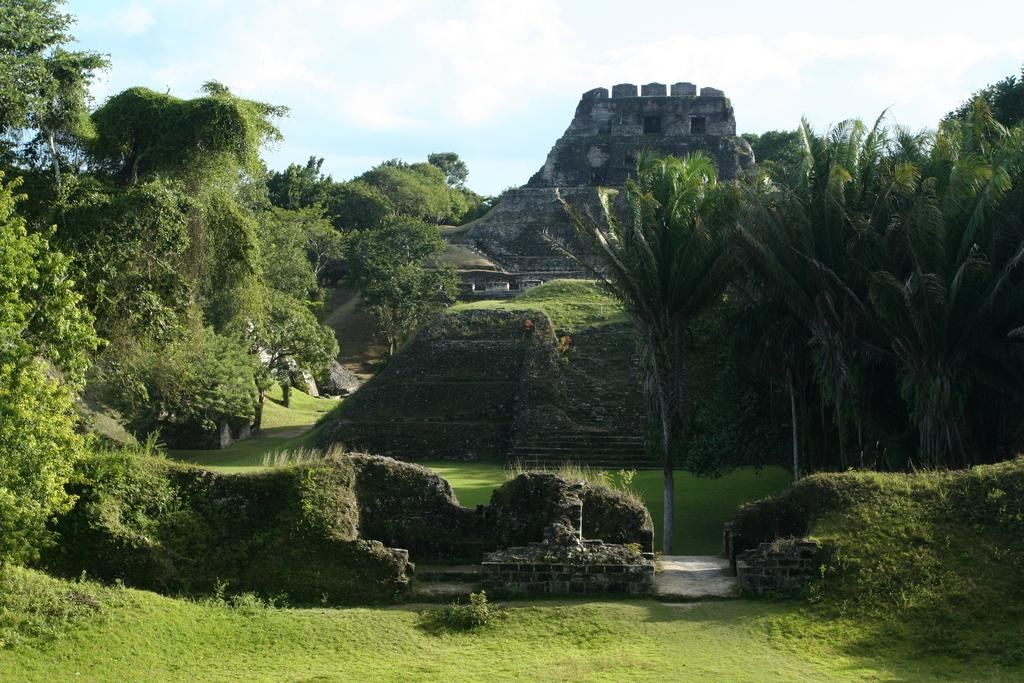What type of structure is visible in the image? There is a fort in the image. What type of vegetation can be seen in the image? There are trees and plants in the image. What is visible in the background of the image? The sky is visible in the background of the image. Where is the nest located in the image? There is no nest present in the image. What type of paste is being used to construct the fort in the image? There is no paste visible in the image, and the construction of the fort is not described. 